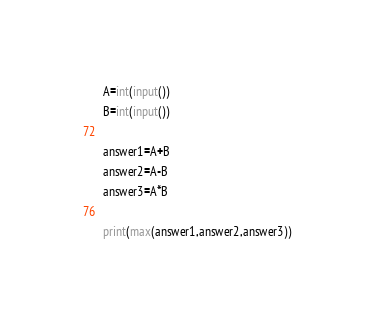<code> <loc_0><loc_0><loc_500><loc_500><_Python_>A=int(input())
B=int(input())

answer1=A+B
answer2=A-B
answer3=A*B

print(max(answer1,answer2,answer3))</code> 